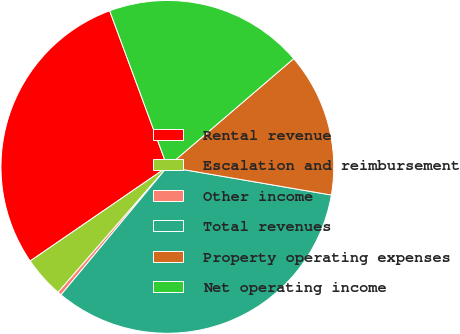Convert chart to OTSL. <chart><loc_0><loc_0><loc_500><loc_500><pie_chart><fcel>Rental revenue<fcel>Escalation and reimbursement<fcel>Other income<fcel>Total revenues<fcel>Property operating expenses<fcel>Net operating income<nl><fcel>28.94%<fcel>4.02%<fcel>0.37%<fcel>33.33%<fcel>13.98%<fcel>19.36%<nl></chart> 